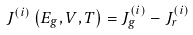Convert formula to latex. <formula><loc_0><loc_0><loc_500><loc_500>J ^ { ( i ) } \left ( E _ { g } , V , T \right ) = J _ { g } ^ { ( i ) } - J _ { r } ^ { ( i ) }</formula> 